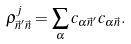Convert formula to latex. <formula><loc_0><loc_0><loc_500><loc_500>\rho ^ { j } _ { \vec { n } ^ { \prime } \vec { n } } = \sum _ { \alpha } c _ { \alpha \vec { n } ^ { \prime } } c _ { \alpha \vec { n } } .</formula> 